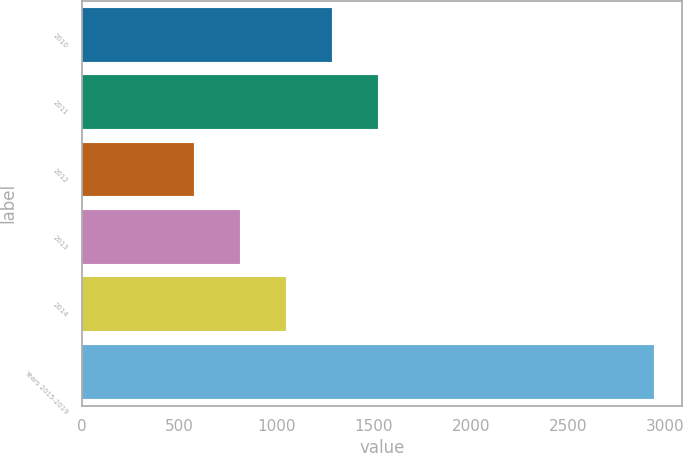<chart> <loc_0><loc_0><loc_500><loc_500><bar_chart><fcel>2010<fcel>2011<fcel>2012<fcel>2013<fcel>2014<fcel>Years 2015-2019<nl><fcel>1284.9<fcel>1521.2<fcel>576<fcel>812.3<fcel>1048.6<fcel>2939<nl></chart> 